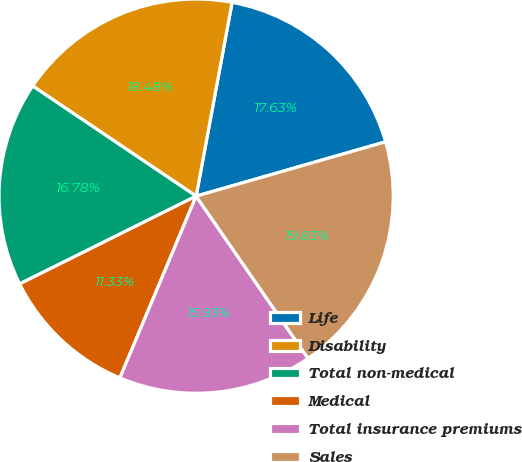<chart> <loc_0><loc_0><loc_500><loc_500><pie_chart><fcel>Life<fcel>Disability<fcel>Total non-medical<fcel>Medical<fcel>Total insurance premiums<fcel>Sales<nl><fcel>17.63%<fcel>18.48%<fcel>16.78%<fcel>11.33%<fcel>15.93%<fcel>19.83%<nl></chart> 